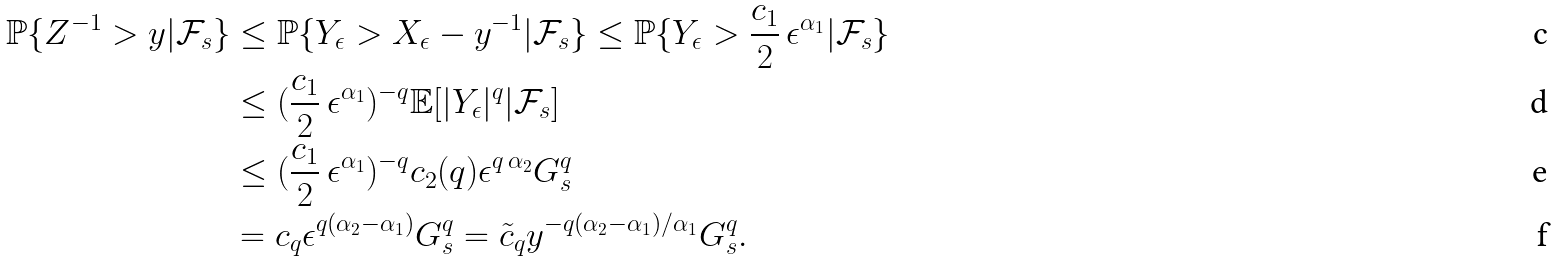<formula> <loc_0><loc_0><loc_500><loc_500>\mathbb { P } \{ Z ^ { - 1 } > y | { \mathcal { F } } _ { s } \} & \leq \mathbb { P } \{ Y _ { \epsilon } > X _ { \epsilon } - y ^ { - 1 } | { \mathcal { F } } _ { s } \} \leq \mathbb { P } \{ Y _ { \epsilon } > \frac { c _ { 1 } } { 2 } \, \epsilon ^ { \alpha _ { 1 } } | { \mathcal { F } } _ { s } \} \\ & \leq ( \frac { c _ { 1 } } { 2 } \, \epsilon ^ { \alpha _ { 1 } } ) ^ { - q } \mathbb { E } [ | Y _ { \epsilon } | ^ { q } | { \mathcal { F } } _ { s } ] \\ & \leq ( \frac { c _ { 1 } } { 2 } \, \epsilon ^ { \alpha _ { 1 } } ) ^ { - q } c _ { 2 } ( q ) \epsilon ^ { q \, \alpha _ { 2 } } G _ { s } ^ { q } \\ & = c _ { q } \epsilon ^ { q ( \alpha _ { 2 } - \alpha _ { 1 } ) } G _ { s } ^ { q } = \tilde { c } _ { q } y ^ { - q ( \alpha _ { 2 } - \alpha _ { 1 } ) / \alpha _ { 1 } } G _ { s } ^ { q } .</formula> 